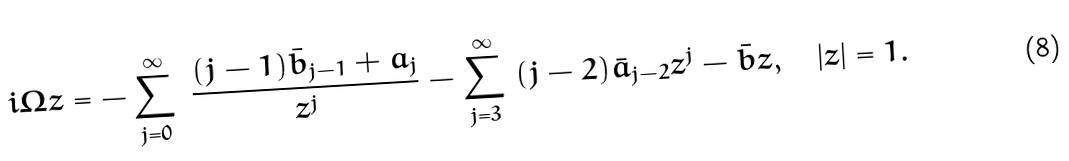Convert formula to latex. <formula><loc_0><loc_0><loc_500><loc_500>i \Omega z = - \sum _ { j = 0 } ^ { \infty } \ \frac { ( j - 1 ) \bar { b } _ { j - 1 } + a _ { j } } { z ^ { j } } - \sum _ { j = 3 } ^ { \infty } \ ( j - 2 ) \bar { a } _ { j - 2 } z ^ { j } - \bar { b } z , \quad | z | = 1 .</formula> 